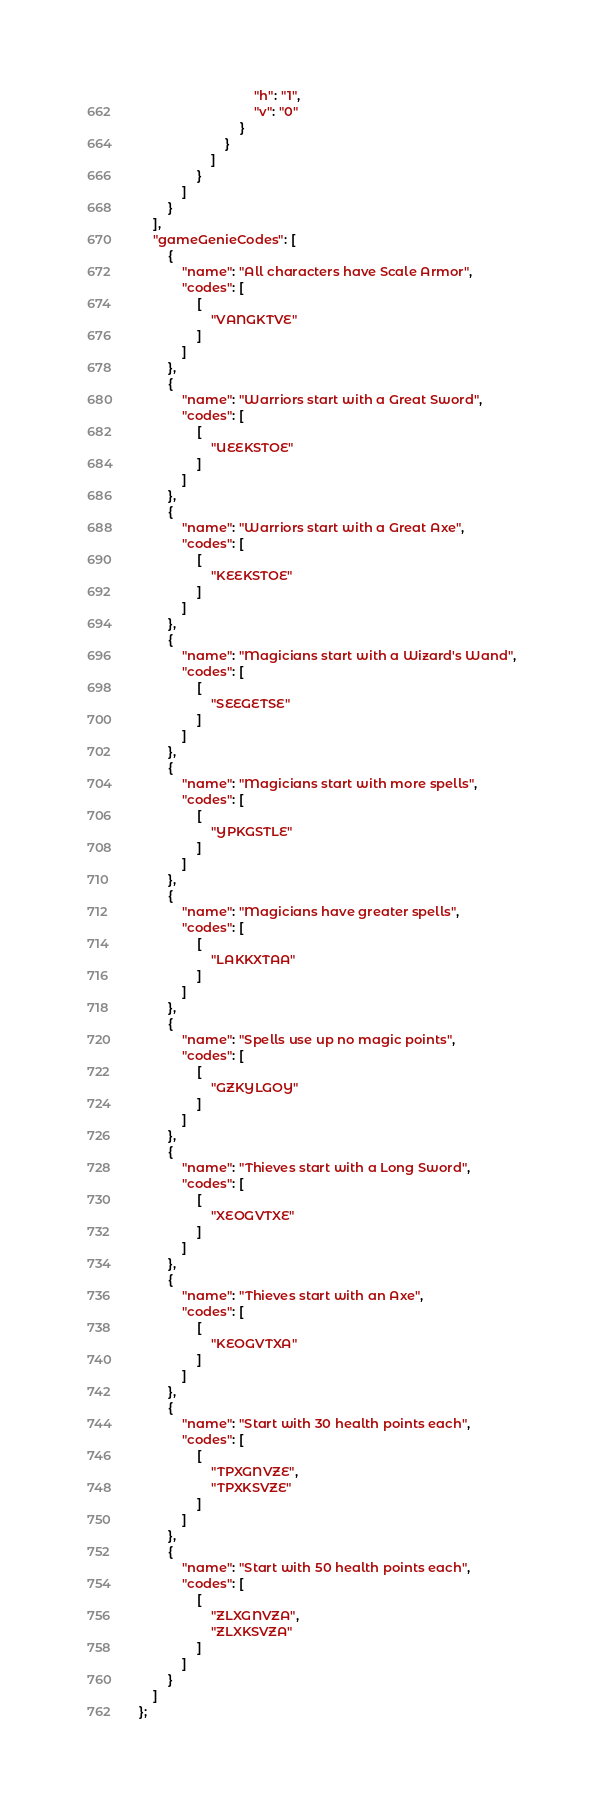Convert code to text. <code><loc_0><loc_0><loc_500><loc_500><_JavaScript_>								"h": "1",
								"v": "0"
							}
						}
					]
				}
			]
		}
	],
	"gameGenieCodes": [
		{
			"name": "All characters have Scale Armor",
			"codes": [
				[
					"VANGKTVE"
				]
			]
		},
		{
			"name": "Warriors start with a Great Sword",
			"codes": [
				[
					"UEEKSTOE"
				]
			]
		},
		{
			"name": "Warriors start with a Great Axe",
			"codes": [
				[
					"KEEKSTOE"
				]
			]
		},
		{
			"name": "Magicians start with a Wizard's Wand",
			"codes": [
				[
					"SEEGETSE"
				]
			]
		},
		{
			"name": "Magicians start with more spells",
			"codes": [
				[
					"YPKGSTLE"
				]
			]
		},
		{
			"name": "Magicians have greater spells",
			"codes": [
				[
					"LAKKXTAA"
				]
			]
		},
		{
			"name": "Spells use up no magic points",
			"codes": [
				[
					"GZKYLGOY"
				]
			]
		},
		{
			"name": "Thieves start with a Long Sword",
			"codes": [
				[
					"XEOGVTXE"
				]
			]
		},
		{
			"name": "Thieves start with an Axe",
			"codes": [
				[
					"KEOGVTXA"
				]
			]
		},
		{
			"name": "Start with 30 health points each",
			"codes": [
				[
					"TPXGNVZE",
					"TPXKSVZE"
				]
			]
		},
		{
			"name": "Start with 50 health points each",
			"codes": [
				[
					"ZLXGNVZA",
					"ZLXKSVZA"
				]
			]
		}
	]
};
</code> 